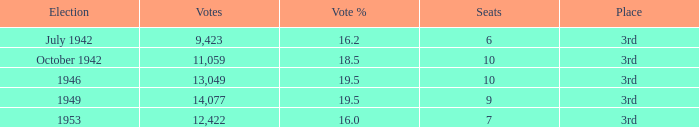Name the sum of votes % more than 19.5 None. 